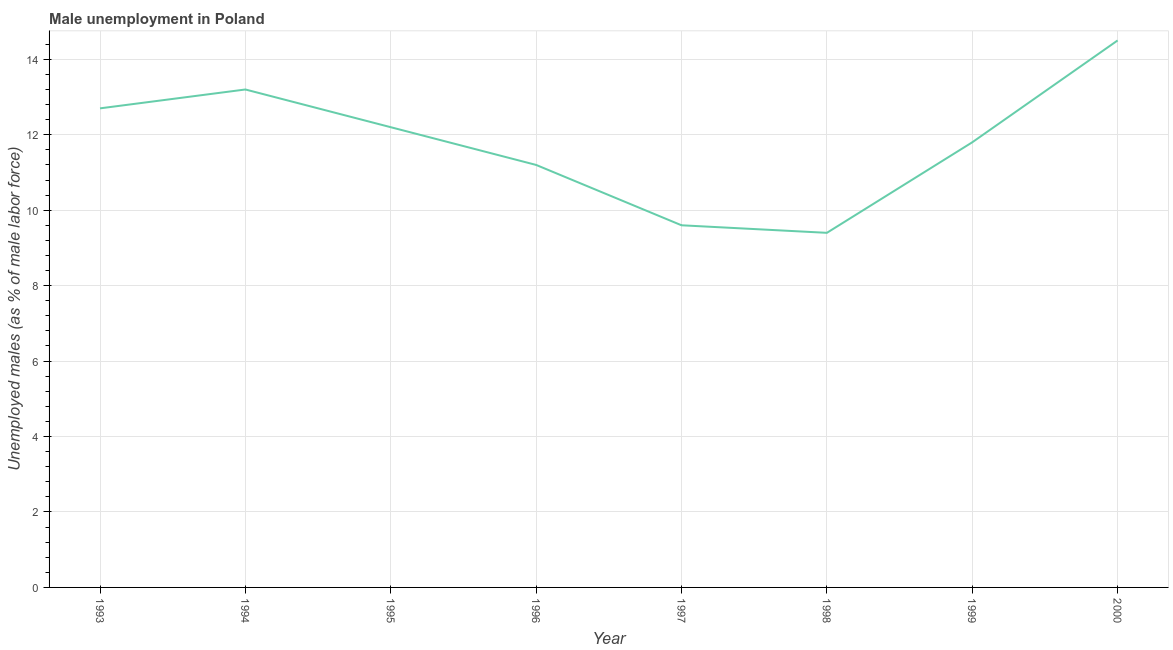What is the unemployed males population in 1995?
Make the answer very short. 12.2. Across all years, what is the maximum unemployed males population?
Offer a terse response. 14.5. Across all years, what is the minimum unemployed males population?
Make the answer very short. 9.4. In which year was the unemployed males population maximum?
Ensure brevity in your answer.  2000. What is the sum of the unemployed males population?
Ensure brevity in your answer.  94.6. What is the average unemployed males population per year?
Your answer should be very brief. 11.82. What is the median unemployed males population?
Offer a very short reply. 12. What is the ratio of the unemployed males population in 1996 to that in 1997?
Provide a succinct answer. 1.17. Is the unemployed males population in 1995 less than that in 1999?
Provide a short and direct response. No. What is the difference between the highest and the second highest unemployed males population?
Keep it short and to the point. 1.3. What is the difference between the highest and the lowest unemployed males population?
Your answer should be compact. 5.1. In how many years, is the unemployed males population greater than the average unemployed males population taken over all years?
Offer a terse response. 4. Does the unemployed males population monotonically increase over the years?
Offer a terse response. No. Does the graph contain any zero values?
Provide a short and direct response. No. What is the title of the graph?
Keep it short and to the point. Male unemployment in Poland. What is the label or title of the X-axis?
Ensure brevity in your answer.  Year. What is the label or title of the Y-axis?
Your response must be concise. Unemployed males (as % of male labor force). What is the Unemployed males (as % of male labor force) in 1993?
Keep it short and to the point. 12.7. What is the Unemployed males (as % of male labor force) of 1994?
Ensure brevity in your answer.  13.2. What is the Unemployed males (as % of male labor force) of 1995?
Provide a short and direct response. 12.2. What is the Unemployed males (as % of male labor force) in 1996?
Keep it short and to the point. 11.2. What is the Unemployed males (as % of male labor force) of 1997?
Your answer should be very brief. 9.6. What is the Unemployed males (as % of male labor force) in 1998?
Your response must be concise. 9.4. What is the Unemployed males (as % of male labor force) of 1999?
Your response must be concise. 11.8. What is the Unemployed males (as % of male labor force) in 2000?
Offer a terse response. 14.5. What is the difference between the Unemployed males (as % of male labor force) in 1993 and 1997?
Your response must be concise. 3.1. What is the difference between the Unemployed males (as % of male labor force) in 1994 and 1996?
Keep it short and to the point. 2. What is the difference between the Unemployed males (as % of male labor force) in 1994 and 1997?
Keep it short and to the point. 3.6. What is the difference between the Unemployed males (as % of male labor force) in 1994 and 1999?
Your response must be concise. 1.4. What is the difference between the Unemployed males (as % of male labor force) in 1994 and 2000?
Keep it short and to the point. -1.3. What is the difference between the Unemployed males (as % of male labor force) in 1995 and 1997?
Your answer should be compact. 2.6. What is the difference between the Unemployed males (as % of male labor force) in 1996 and 1997?
Keep it short and to the point. 1.6. What is the difference between the Unemployed males (as % of male labor force) in 1996 and 1998?
Provide a succinct answer. 1.8. What is the difference between the Unemployed males (as % of male labor force) in 1997 and 1998?
Keep it short and to the point. 0.2. What is the difference between the Unemployed males (as % of male labor force) in 1998 and 1999?
Give a very brief answer. -2.4. What is the difference between the Unemployed males (as % of male labor force) in 1998 and 2000?
Ensure brevity in your answer.  -5.1. What is the ratio of the Unemployed males (as % of male labor force) in 1993 to that in 1995?
Offer a terse response. 1.04. What is the ratio of the Unemployed males (as % of male labor force) in 1993 to that in 1996?
Offer a terse response. 1.13. What is the ratio of the Unemployed males (as % of male labor force) in 1993 to that in 1997?
Ensure brevity in your answer.  1.32. What is the ratio of the Unemployed males (as % of male labor force) in 1993 to that in 1998?
Keep it short and to the point. 1.35. What is the ratio of the Unemployed males (as % of male labor force) in 1993 to that in 1999?
Provide a succinct answer. 1.08. What is the ratio of the Unemployed males (as % of male labor force) in 1993 to that in 2000?
Your response must be concise. 0.88. What is the ratio of the Unemployed males (as % of male labor force) in 1994 to that in 1995?
Make the answer very short. 1.08. What is the ratio of the Unemployed males (as % of male labor force) in 1994 to that in 1996?
Offer a very short reply. 1.18. What is the ratio of the Unemployed males (as % of male labor force) in 1994 to that in 1997?
Ensure brevity in your answer.  1.38. What is the ratio of the Unemployed males (as % of male labor force) in 1994 to that in 1998?
Keep it short and to the point. 1.4. What is the ratio of the Unemployed males (as % of male labor force) in 1994 to that in 1999?
Keep it short and to the point. 1.12. What is the ratio of the Unemployed males (as % of male labor force) in 1994 to that in 2000?
Provide a succinct answer. 0.91. What is the ratio of the Unemployed males (as % of male labor force) in 1995 to that in 1996?
Your answer should be compact. 1.09. What is the ratio of the Unemployed males (as % of male labor force) in 1995 to that in 1997?
Your response must be concise. 1.27. What is the ratio of the Unemployed males (as % of male labor force) in 1995 to that in 1998?
Your answer should be compact. 1.3. What is the ratio of the Unemployed males (as % of male labor force) in 1995 to that in 1999?
Offer a terse response. 1.03. What is the ratio of the Unemployed males (as % of male labor force) in 1995 to that in 2000?
Your response must be concise. 0.84. What is the ratio of the Unemployed males (as % of male labor force) in 1996 to that in 1997?
Ensure brevity in your answer.  1.17. What is the ratio of the Unemployed males (as % of male labor force) in 1996 to that in 1998?
Offer a very short reply. 1.19. What is the ratio of the Unemployed males (as % of male labor force) in 1996 to that in 1999?
Ensure brevity in your answer.  0.95. What is the ratio of the Unemployed males (as % of male labor force) in 1996 to that in 2000?
Your answer should be very brief. 0.77. What is the ratio of the Unemployed males (as % of male labor force) in 1997 to that in 1998?
Your answer should be very brief. 1.02. What is the ratio of the Unemployed males (as % of male labor force) in 1997 to that in 1999?
Provide a succinct answer. 0.81. What is the ratio of the Unemployed males (as % of male labor force) in 1997 to that in 2000?
Give a very brief answer. 0.66. What is the ratio of the Unemployed males (as % of male labor force) in 1998 to that in 1999?
Give a very brief answer. 0.8. What is the ratio of the Unemployed males (as % of male labor force) in 1998 to that in 2000?
Ensure brevity in your answer.  0.65. What is the ratio of the Unemployed males (as % of male labor force) in 1999 to that in 2000?
Your answer should be compact. 0.81. 